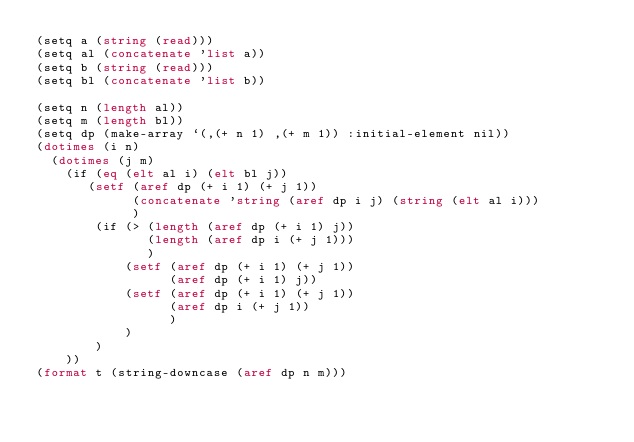<code> <loc_0><loc_0><loc_500><loc_500><_Lisp_>(setq a (string (read)))
(setq al (concatenate 'list a))
(setq b (string (read)))
(setq bl (concatenate 'list b))

(setq n (length al))
(setq m (length bl))
(setq dp (make-array `(,(+ n 1) ,(+ m 1)) :initial-element nil))
(dotimes (i n)
  (dotimes (j m)
    (if (eq (elt al i) (elt bl j))
       (setf (aref dp (+ i 1) (+ j 1))
             (concatenate 'string (aref dp i j) (string (elt al i)))
             )
        (if (> (length (aref dp (+ i 1) j))
               (length (aref dp i (+ j 1)))
               )
            (setf (aref dp (+ i 1) (+ j 1))
                  (aref dp (+ i 1) j))
            (setf (aref dp (+ i 1) (+ j 1))
                  (aref dp i (+ j 1))
                  )
            )
        )
    ))
(format t (string-downcase (aref dp n m)))
</code> 